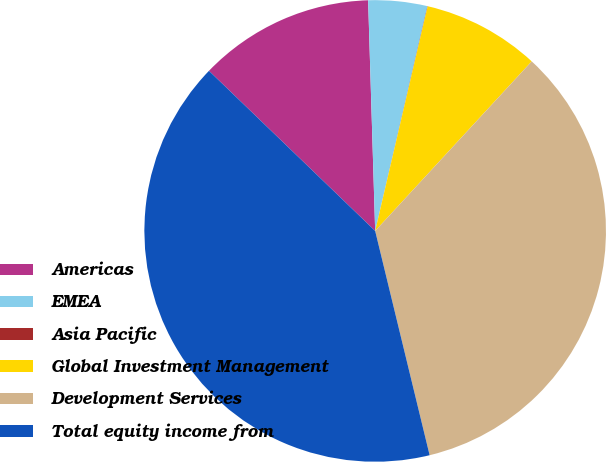<chart> <loc_0><loc_0><loc_500><loc_500><pie_chart><fcel>Americas<fcel>EMEA<fcel>Asia Pacific<fcel>Global Investment Management<fcel>Development Services<fcel>Total equity income from<nl><fcel>12.31%<fcel>4.12%<fcel>0.02%<fcel>8.21%<fcel>34.34%<fcel>40.99%<nl></chart> 